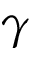Convert formula to latex. <formula><loc_0><loc_0><loc_500><loc_500>\gamma</formula> 